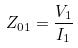Convert formula to latex. <formula><loc_0><loc_0><loc_500><loc_500>Z _ { 0 1 } = \frac { V _ { 1 } } { I _ { 1 } }</formula> 